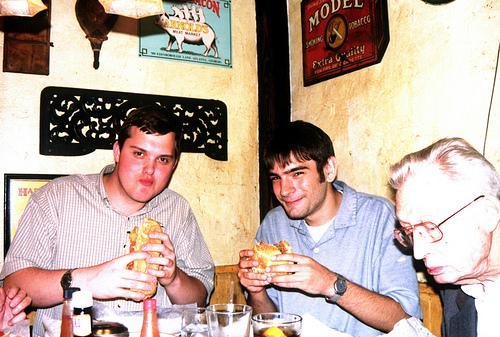Question: where are they sitting?
Choices:
A. At a picnic table.
B. At a restaurant.
C. At home.
D. In church.
Answer with the letter. Answer: B Question: what are the boys eating?
Choices:
A. Sandwiches.
B. Hotdogs.
C. Crackers.
D. Pizza.
Answer with the letter. Answer: A Question: how many people's faces are in the picture?
Choices:
A. 2.
B. 1.
C. 4.
D. 3.
Answer with the letter. Answer: D Question: how many glasses are on the table?
Choices:
A. Three.
B. Two.
C. One.
D. Four.
Answer with the letter. Answer: A Question: what color are the walls?
Choices:
A. Beige.
B. White.
C. Creme.
D. Blue.
Answer with the letter. Answer: C 